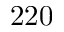<formula> <loc_0><loc_0><loc_500><loc_500>2 2 0</formula> 